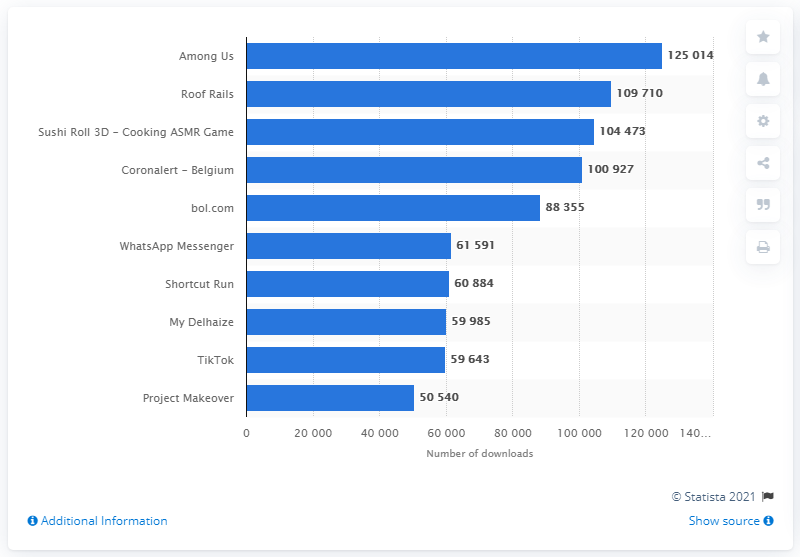List a handful of essential elements in this visual. In January 2021, Among Us! was downloaded a total of 125,014 times. 